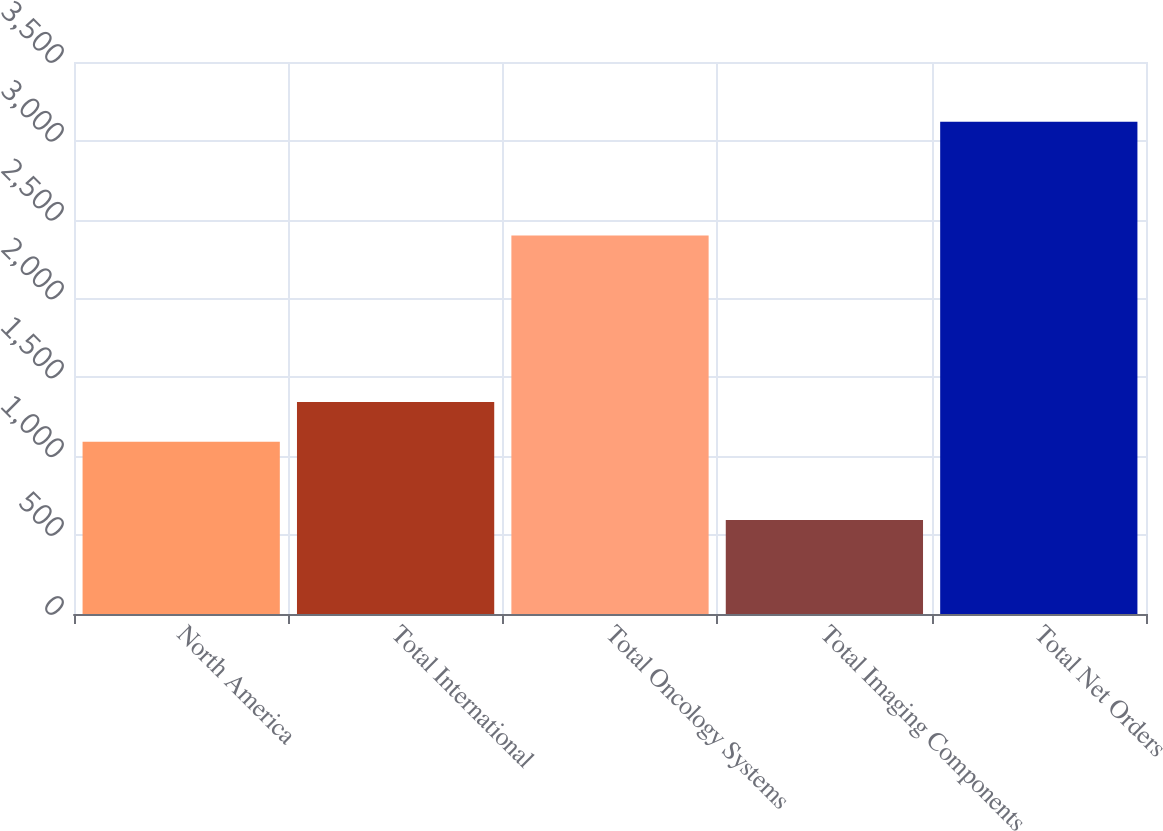<chart> <loc_0><loc_0><loc_500><loc_500><bar_chart><fcel>North America<fcel>Total International<fcel>Total Oncology Systems<fcel>Total Imaging Components<fcel>Total Net Orders<nl><fcel>1091.4<fcel>1344.04<fcel>2400.1<fcel>595.5<fcel>3121.9<nl></chart> 